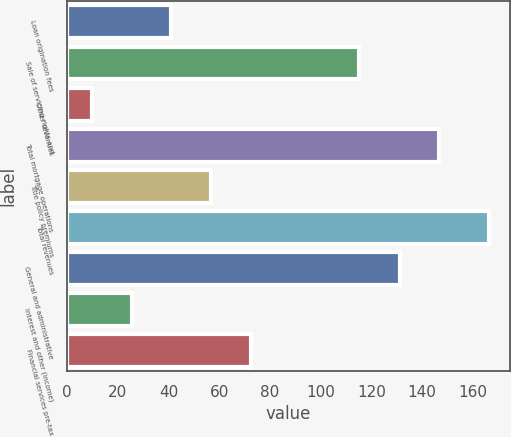<chart> <loc_0><loc_0><loc_500><loc_500><bar_chart><fcel>Loan origination fees<fcel>Sale of servicing rights and<fcel>Other revenues<fcel>Total mortgage operations<fcel>Title policy premiums<fcel>Total revenues<fcel>General and administrative<fcel>Interest and other (income)<fcel>Financial services pre-tax<nl><fcel>41.04<fcel>115.27<fcel>9.7<fcel>146.87<fcel>56.71<fcel>166.4<fcel>131.2<fcel>25.37<fcel>72.38<nl></chart> 